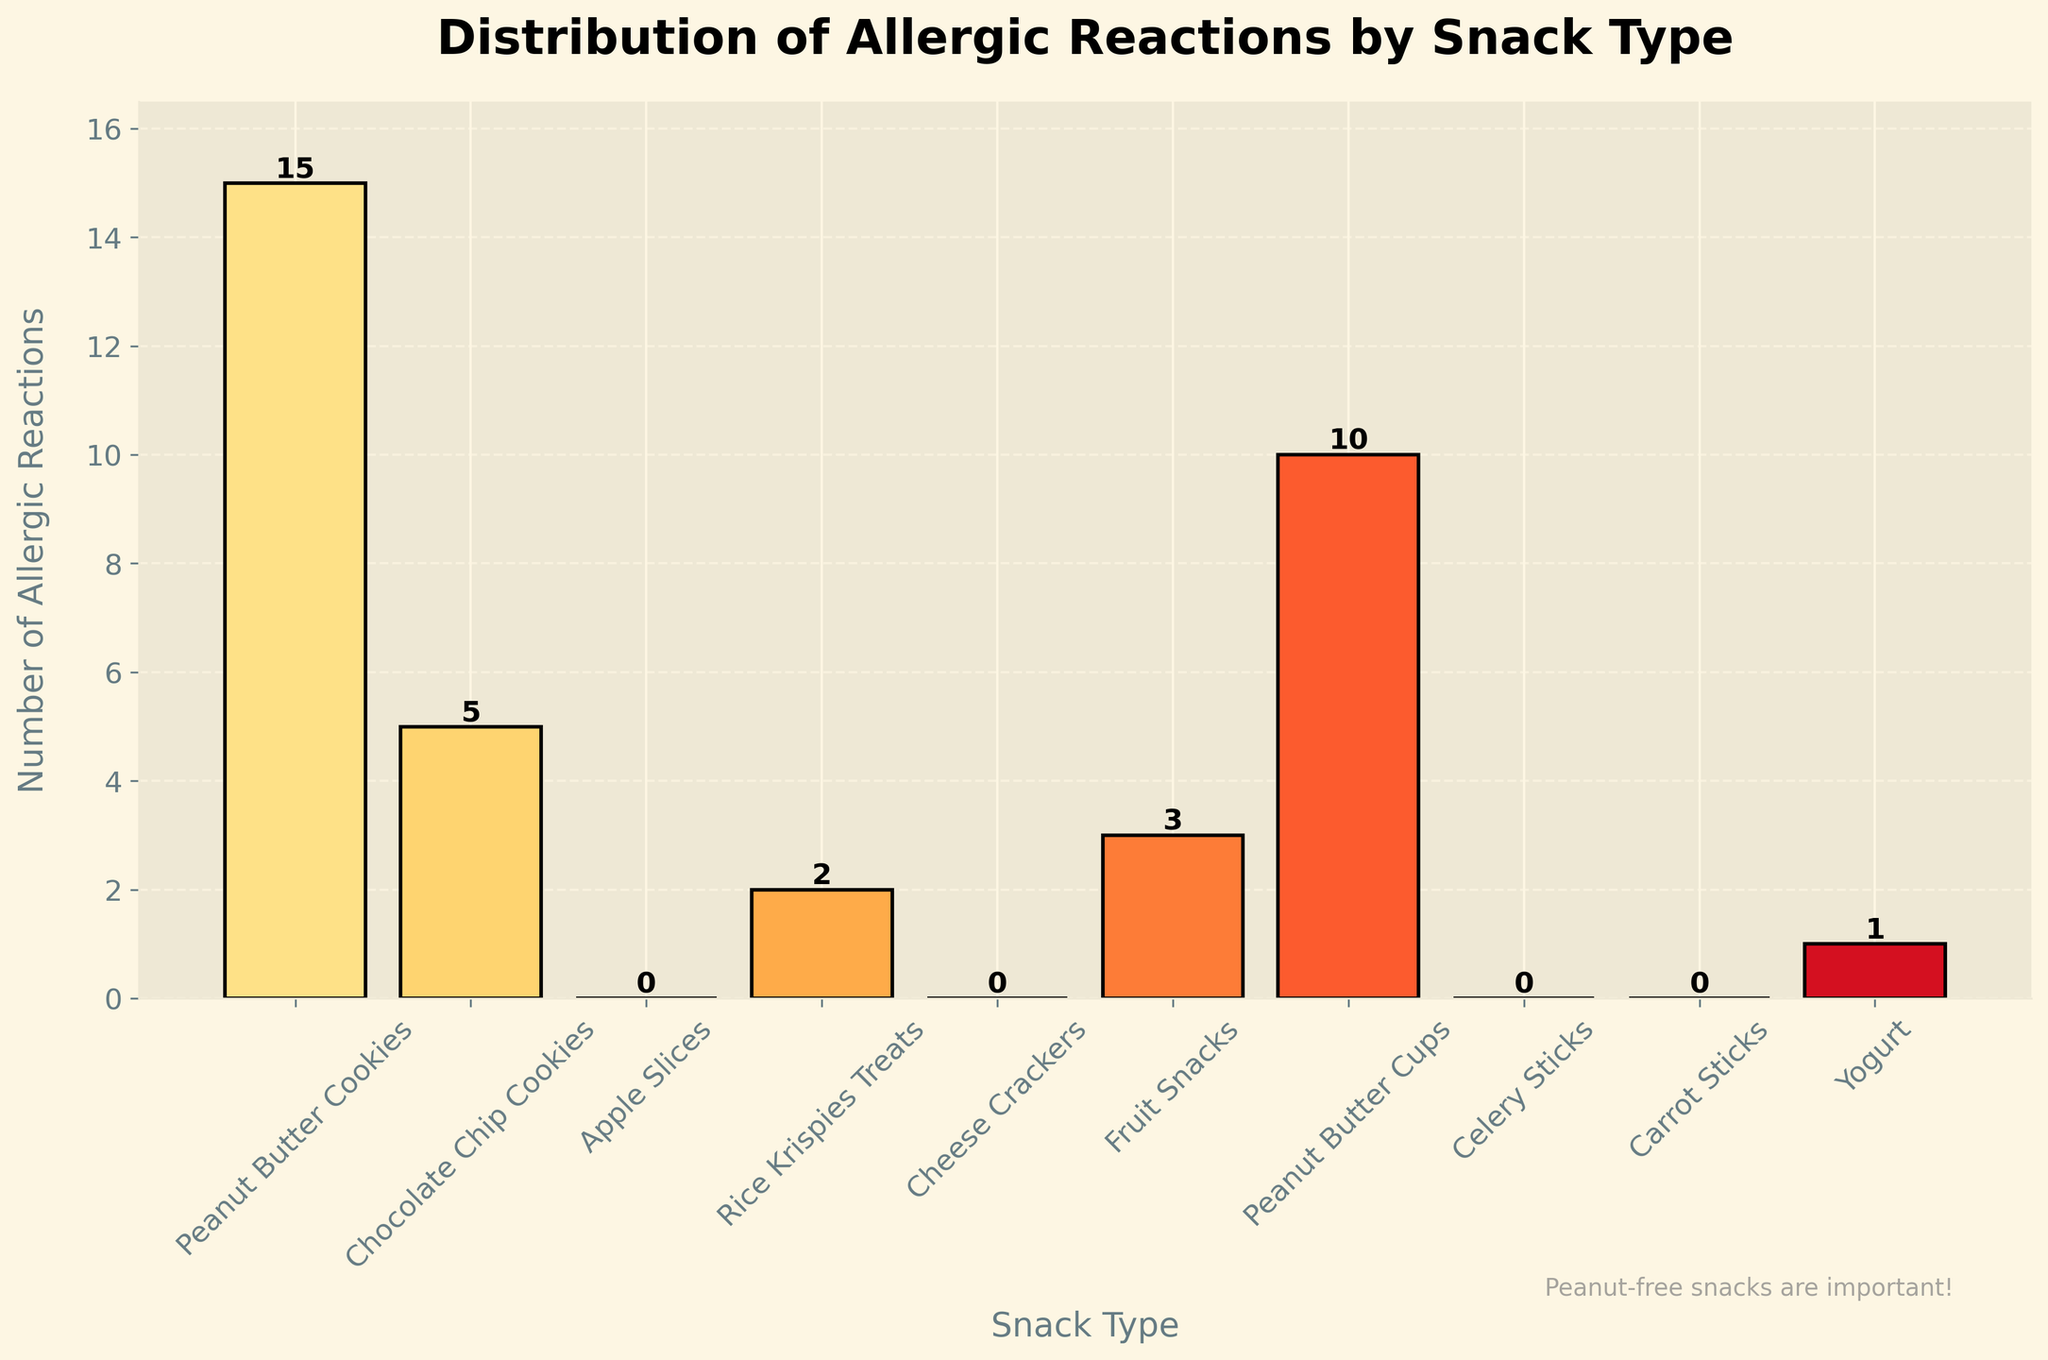What is the title of the figure? The title is usually displayed at the top of the figure and provides an overview of the content. By reading the title, we see that it says 'Distribution of Allergic Reactions by Snack Type'.
Answer: Distribution of Allergic Reactions by Snack Type How many types of snacks have zero allergic reactions? By observing the bar heights, we can see that Apple Slices, Cheese Crackers, Celery Sticks, and Carrot Sticks have bars with a height of zero.
Answer: 4 Which snack type has the highest number of allergic reactions? Looking at the bars, the tallest bar corresponds to Peanut Butter Cookies with a count of 15.
Answer: Peanut Butter Cookies What is the range of the y-axis? The range of the y-axis can be determined by looking at the numbers on the vertical axis. It starts at 0 and goes up to slightly above 15.
Answer: 0 to ~16.5 How many allergic reactions are there for Chocolate Chip Cookies and Fruit Snacks combined? Chocolate Chip Cookies have a bar height of 5 and Fruit Snacks have a bar height of 3. Adding them together gives 5 + 3 = 8.
Answer: 8 Which snack type has more allergic reactions: Rice Krispies Treats or Yogurt? Comparing the heights of their bars, Rice Krispies Treats has 2 reactions while Yogurt has 1. Therefore, Rice Krispies Treats has more.
Answer: Rice Krispies Treats How many more allergic reactions are caused by Peanut Butter Cookies compared to Peanut Butter Cups? Peanut Butter Cookies have 15 reactions while Peanut Butter Cups have 10. The difference is 15 - 10 = 5.
Answer: 5 What is the average number of allergic reactions across all snack types? Adding all the reaction counts and dividing by the number of snack types: (15 + 5 + 0 + 2 + 0 + 3 + 10 + 0 + 0 + 1) / 10 = 36 / 10 = 3.6.
Answer: 3.6 Which snacks have a count less than or equal to 1 reaction? Understanding from the bar heights, the snacks are Apple Slices (0), Cheese Crackers (0), Celery Sticks (0), Carrot Sticks (0), and Yogurt (1).
Answer: Apple Slices, Cheese Crackers, Celery Sticks, Carrot Sticks, and Yogurt Do more snacks have zero reactions or more than zero reactions? Count the snack types: there are 5 with more than zero (Peanut Butter Cookies, Chocolate Chip Cookies, Rice Krispies Treats, Fruit Snacks, Peanut Butter Cups, Yogurt) and 4 with zero (Apple Slices, Cheese Crackers, Celery Sticks, Carrot Sticks).
Answer: More than zero reaction 